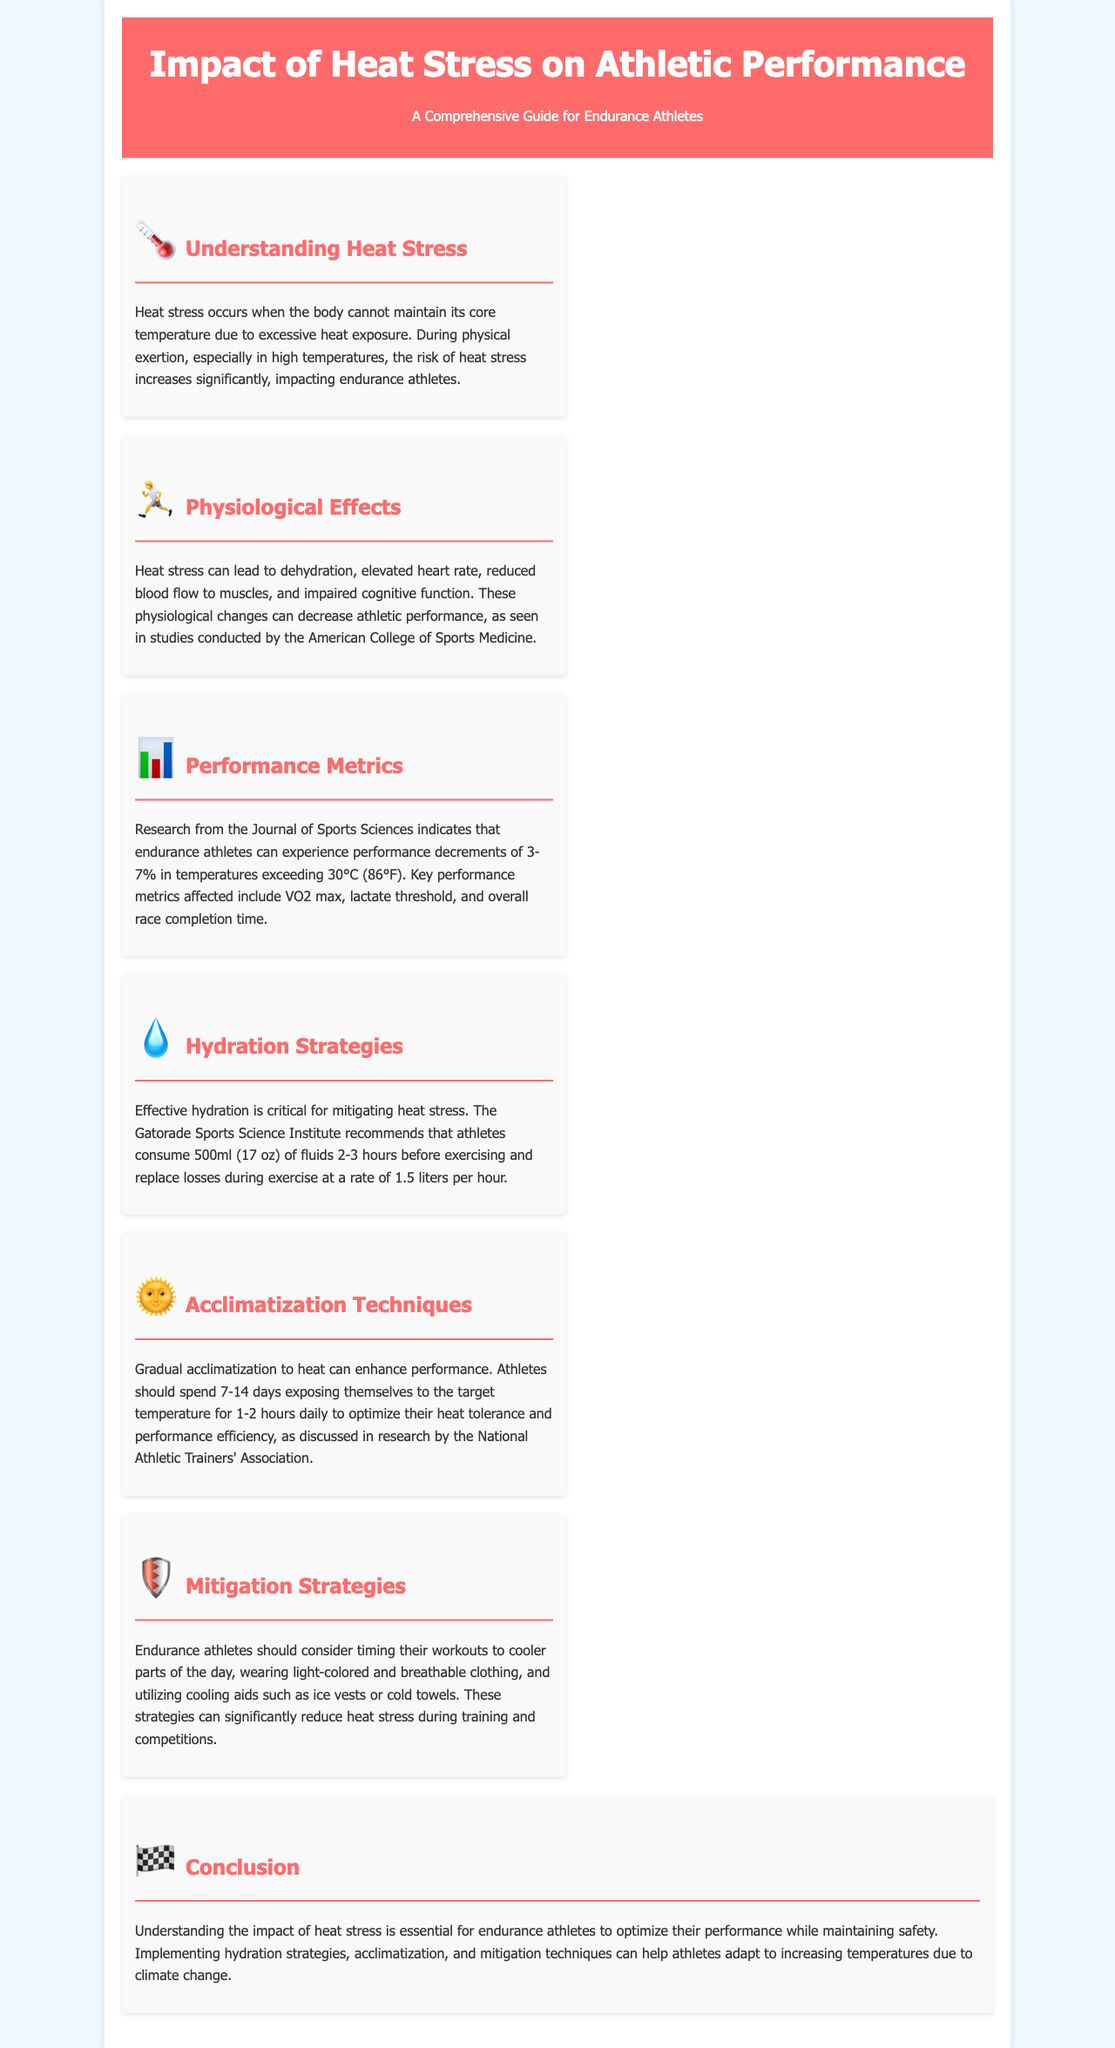what is heat stress? Heat stress occurs when the body cannot maintain its core temperature due to excessive heat exposure.
Answer: excessive heat exposure what is the recommended fluid intake before exercising? Athletes should consume 500ml (17 oz) of fluids 2-3 hours before exercising.
Answer: 500ml (17 oz) how much performance decrement can athletes experience in high temperatures? Endurance athletes can experience performance decrements of 3-7% in temperatures exceeding 30°C (86°F).
Answer: 3-7% how long should athletes acclimatize to heat? Athletes should spend 7-14 days acclimatizing to heat for optimal performance.
Answer: 7-14 days what are some mitigation strategies for heat stress? Strategies include timing workouts to cooler parts of the day, wearing light-colored clothing, and using cooling aids.
Answer: cooler parts of the day what physiological effect does heat stress have on heart rate? Heat stress can lead to an elevated heart rate.
Answer: elevated heart rate what organization recommends hydration strategies? The Gatorade Sports Science Institute recommends hydration strategies.
Answer: Gatorade Sports Science Institute how many liters of fluid should be replaced during exercise? Athletes should replace losses during exercise at a rate of 1.5 liters per hour.
Answer: 1.5 liters per hour 